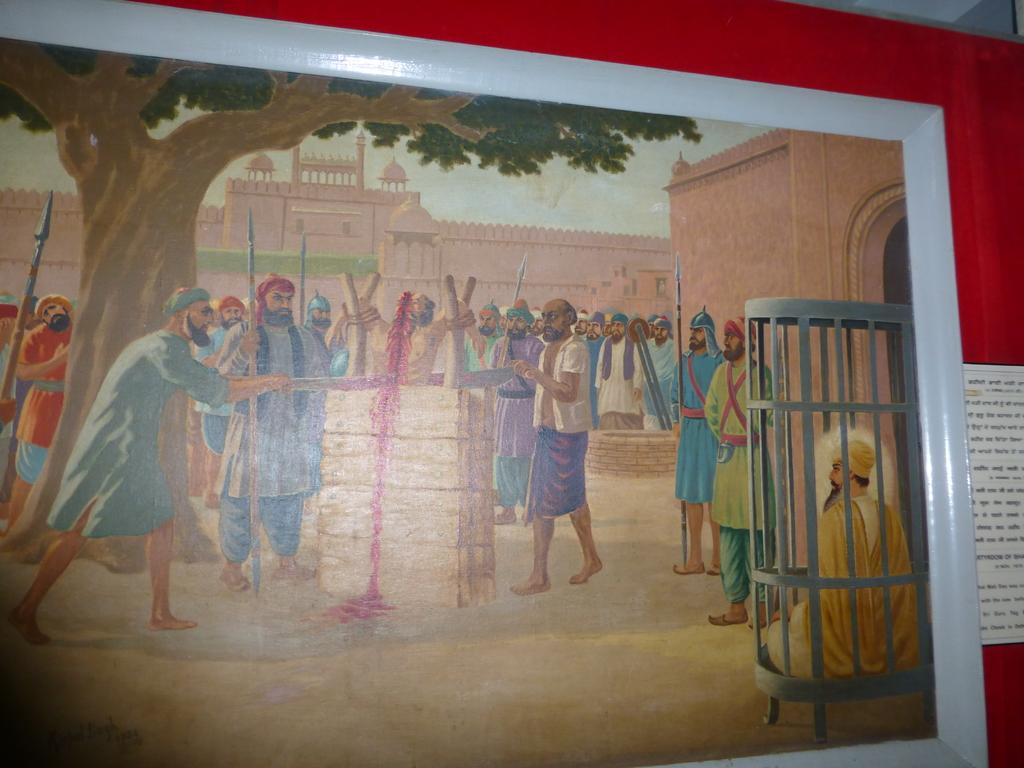What is depicted on the wall in the image? There is a wall painting in the image. Where is the wall painting located? The wall painting is on a wall. What else can be seen on the wall in the image? There is a board on the wall. What information is provided on the board? The board has some text on it. Can you tell me how many actors are standing on the quicksand in the image? There is no quicksand or actors present in the image. 